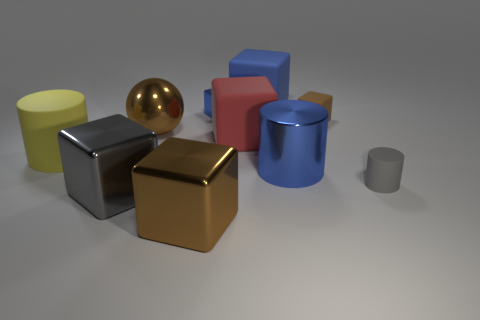Are there any small shiny things?
Make the answer very short. Yes. What color is the large cylinder on the right side of the big blue matte object?
Make the answer very short. Blue. There is a red block that is the same size as the yellow rubber cylinder; what material is it?
Provide a short and direct response. Rubber. How many other objects are there of the same material as the small blue object?
Ensure brevity in your answer.  4. There is a large thing that is both on the right side of the big brown block and behind the big red rubber block; what color is it?
Your answer should be compact. Blue. How many objects are big cylinders to the left of the large blue metallic thing or red matte cylinders?
Keep it short and to the point. 1. What number of other things are the same color as the sphere?
Your answer should be very brief. 2. Is the number of small metallic things in front of the tiny matte cube the same as the number of small brown rubber objects?
Your answer should be very brief. No. There is a big metal object to the right of the large blue rubber block that is right of the brown ball; how many small cubes are on the right side of it?
Provide a short and direct response. 1. There is a metallic cylinder; does it have the same size as the brown thing that is in front of the large sphere?
Offer a terse response. Yes. 